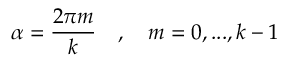Convert formula to latex. <formula><loc_0><loc_0><loc_500><loc_500>\alpha = \frac { 2 \pi m } { k } \quad , \quad m = 0 , \dots , k - 1</formula> 